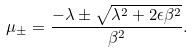<formula> <loc_0><loc_0><loc_500><loc_500>\mu _ { \pm } = \frac { - \lambda \pm \sqrt { \lambda ^ { 2 } + 2 \epsilon \beta ^ { 2 } } } { \beta ^ { 2 } } .</formula> 